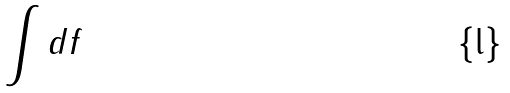Convert formula to latex. <formula><loc_0><loc_0><loc_500><loc_500>\int d f</formula> 